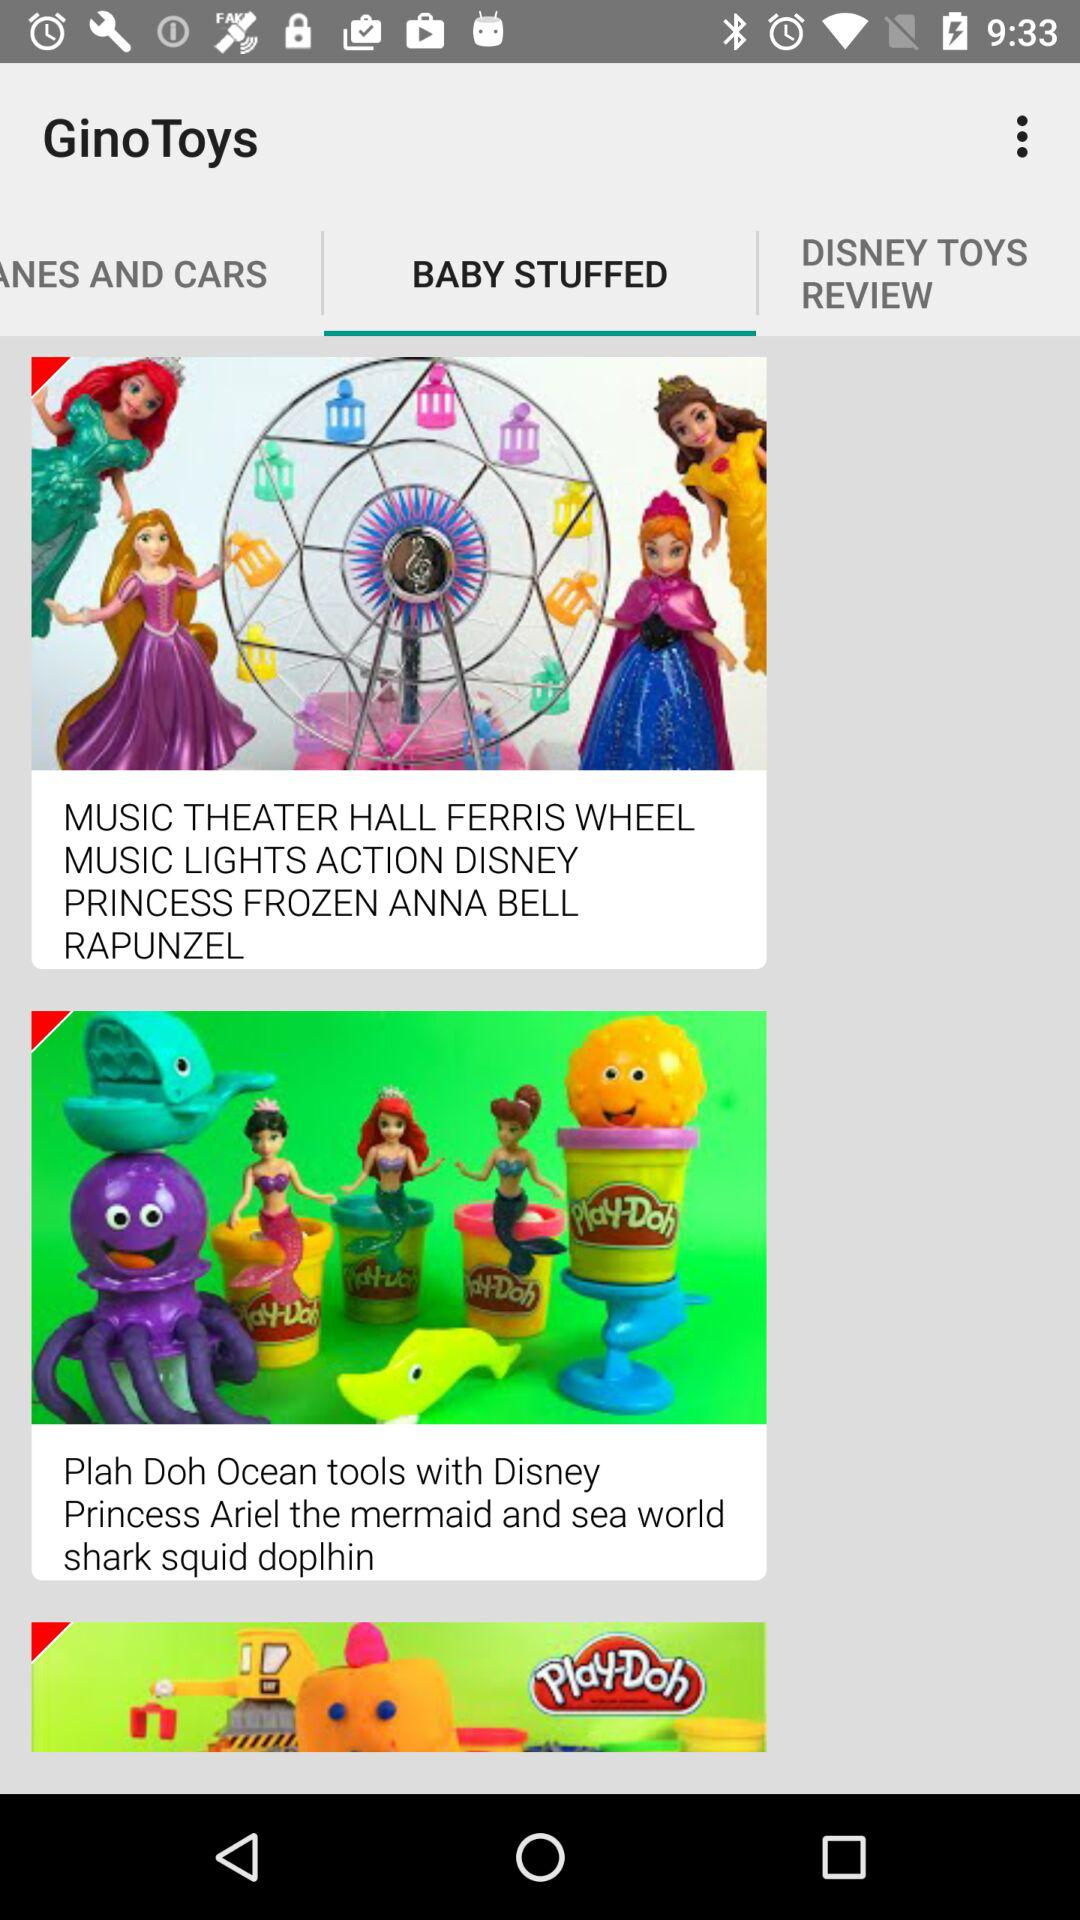How much does the 'MUSIC THEATER HALL FERRIS WHEEL" cost?
When the provided information is insufficient, respond with <no answer>. <no answer> 